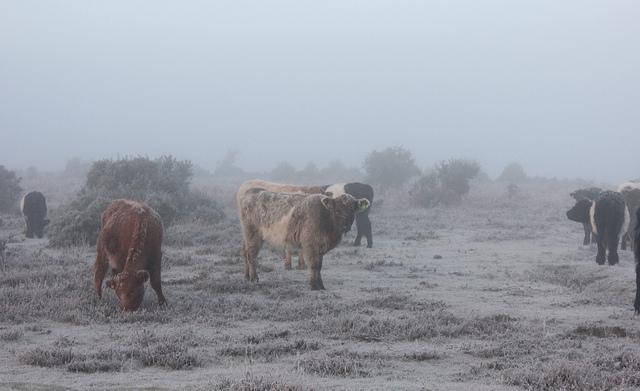How many cows are eating?
Give a very brief answer. 2. How many cow are there?
Give a very brief answer. 6. How many cows can be seen?
Give a very brief answer. 3. How many people are at the table?
Give a very brief answer. 0. 